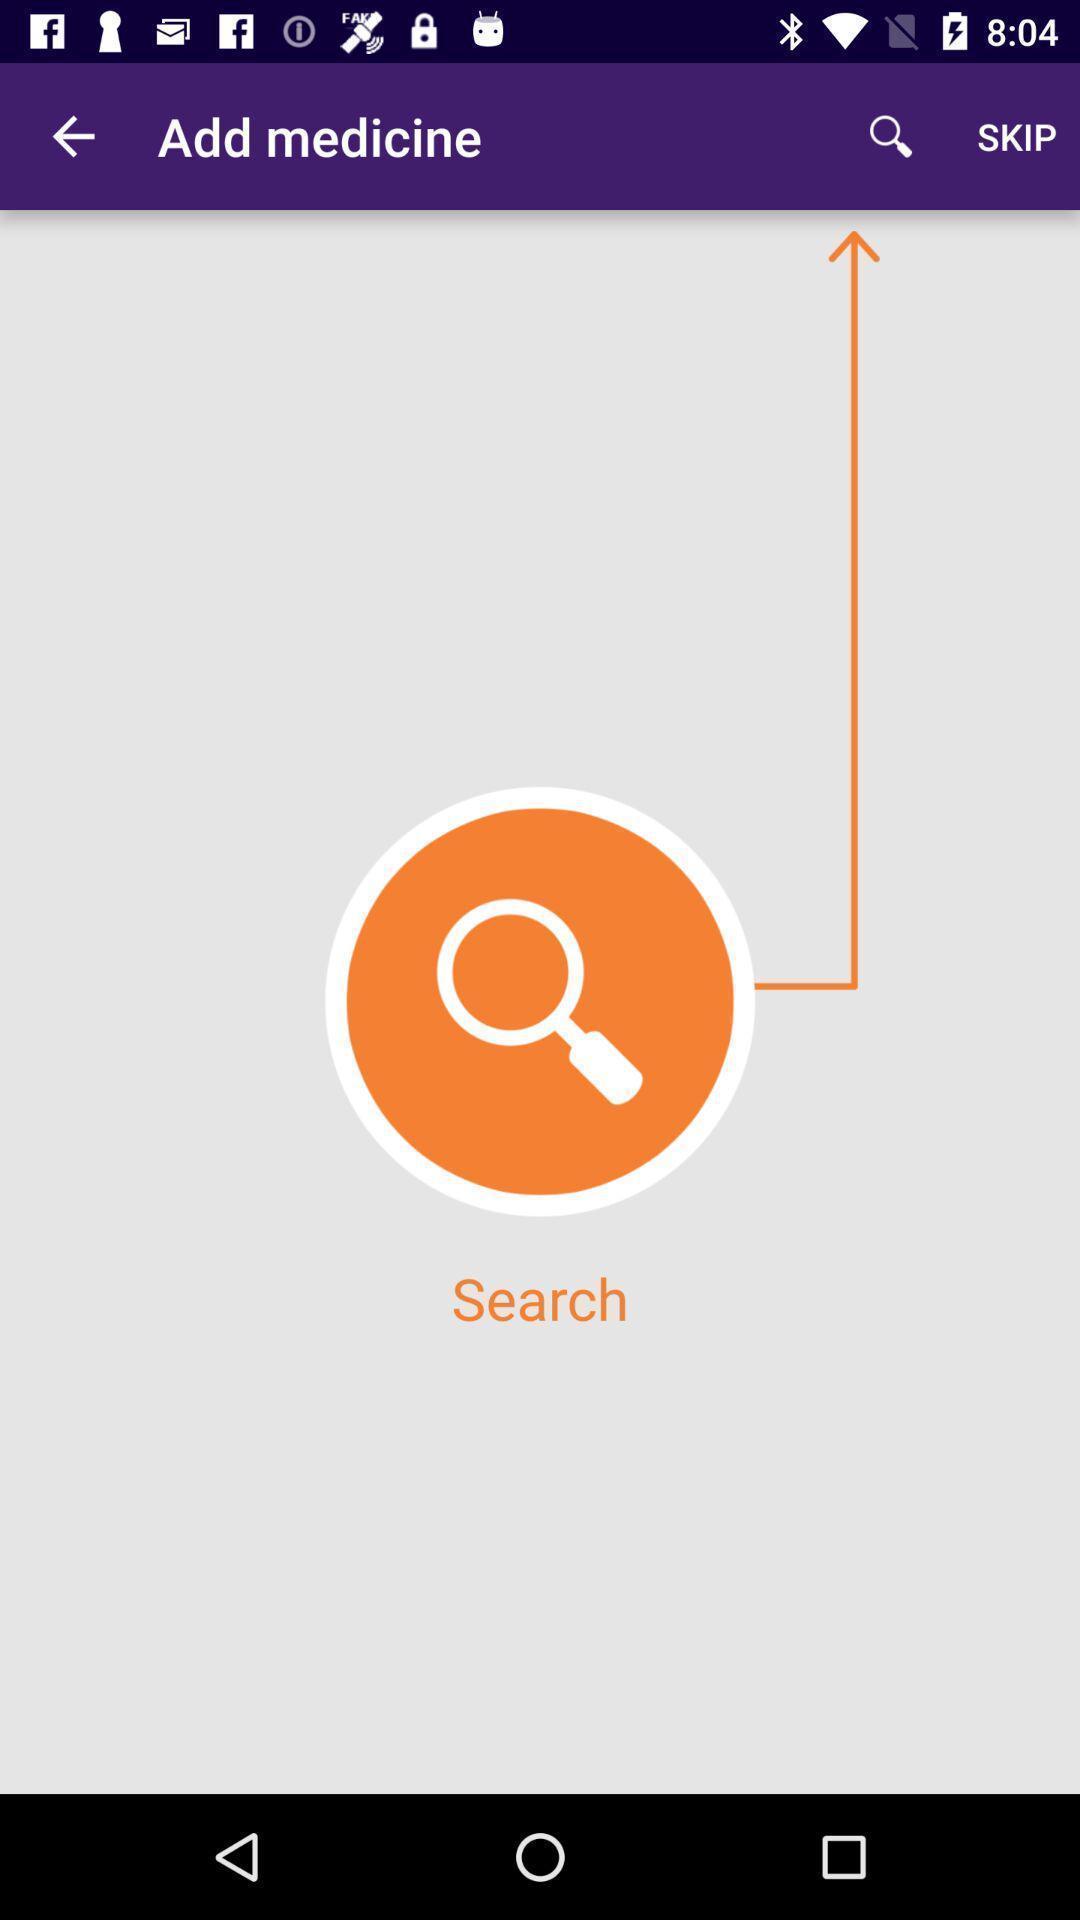What details can you identify in this image? Search page on a medicine information app. 